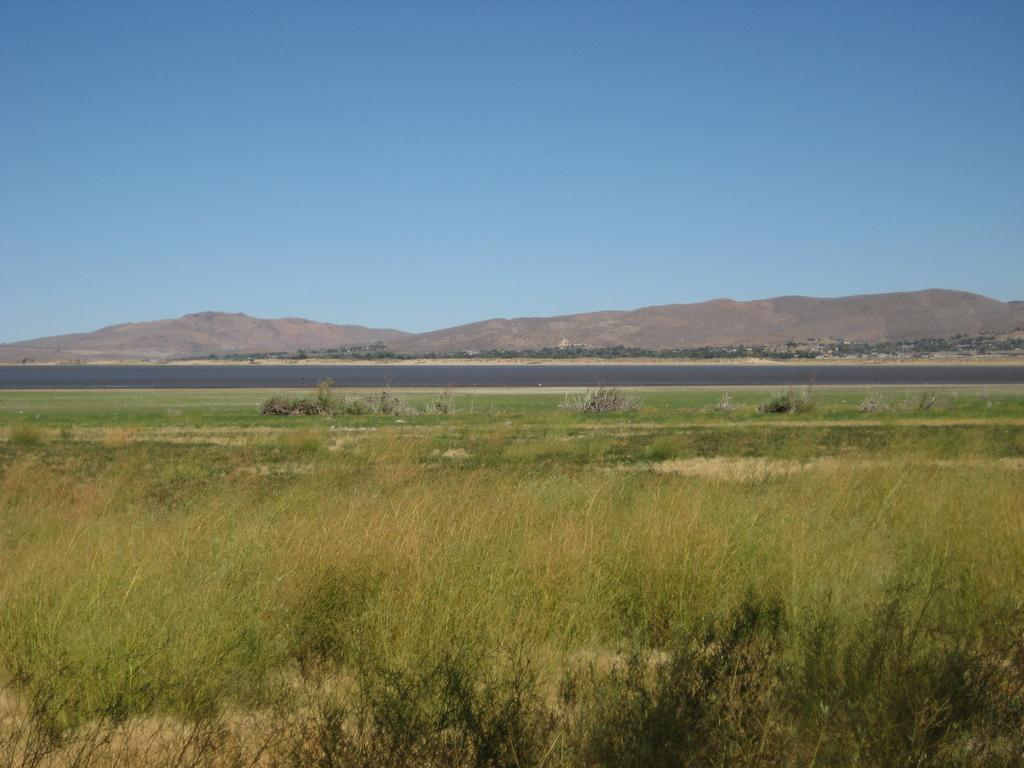What is located in the foreground of the image? There is a group of plants in the foreground of the image. What can be seen in the background of the image? Water, mountains, and the sky are visible in the background of the image. Where is the toothpaste located in the image? There is no toothpaste present in the image. What type of motion can be observed in the image? The image is a still photograph, so there is no motion observable in the image. 